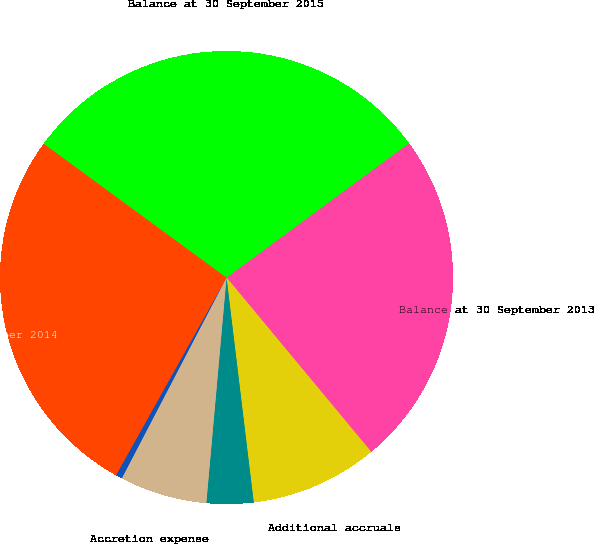Convert chart. <chart><loc_0><loc_0><loc_500><loc_500><pie_chart><fcel>Balance at 30 September 2013<fcel>Additional accruals<fcel>Liabilities settled<fcel>Accretion expense<fcel>Currency translation<fcel>Balance at 30 September 2014<fcel>Balance at 30 September 2015<nl><fcel>24.07%<fcel>9.11%<fcel>3.34%<fcel>6.23%<fcel>0.46%<fcel>26.95%<fcel>29.84%<nl></chart> 